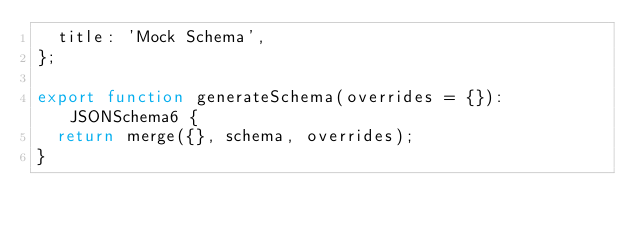Convert code to text. <code><loc_0><loc_0><loc_500><loc_500><_TypeScript_>  title: 'Mock Schema',
};

export function generateSchema(overrides = {}): JSONSchema6 {
  return merge({}, schema, overrides);
}
</code> 